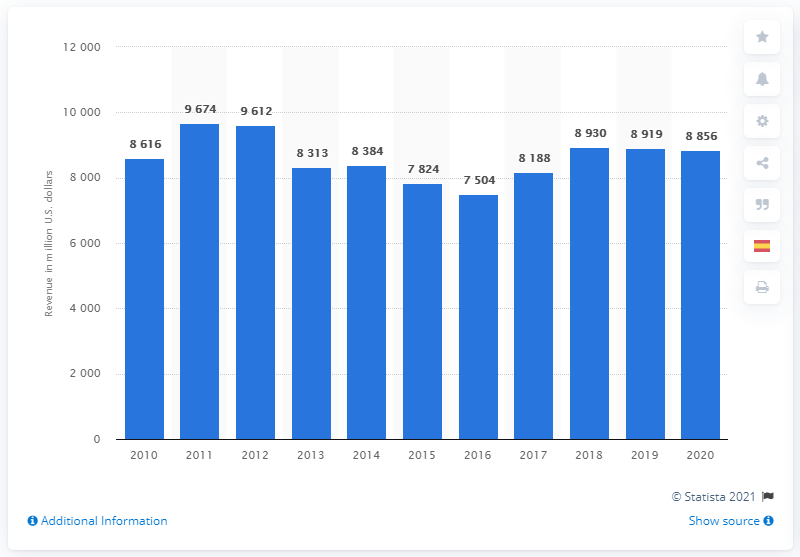Identify some key points in this picture. In 2020, Air Products and Chemicals generated approximately $88,560 in revenue. 